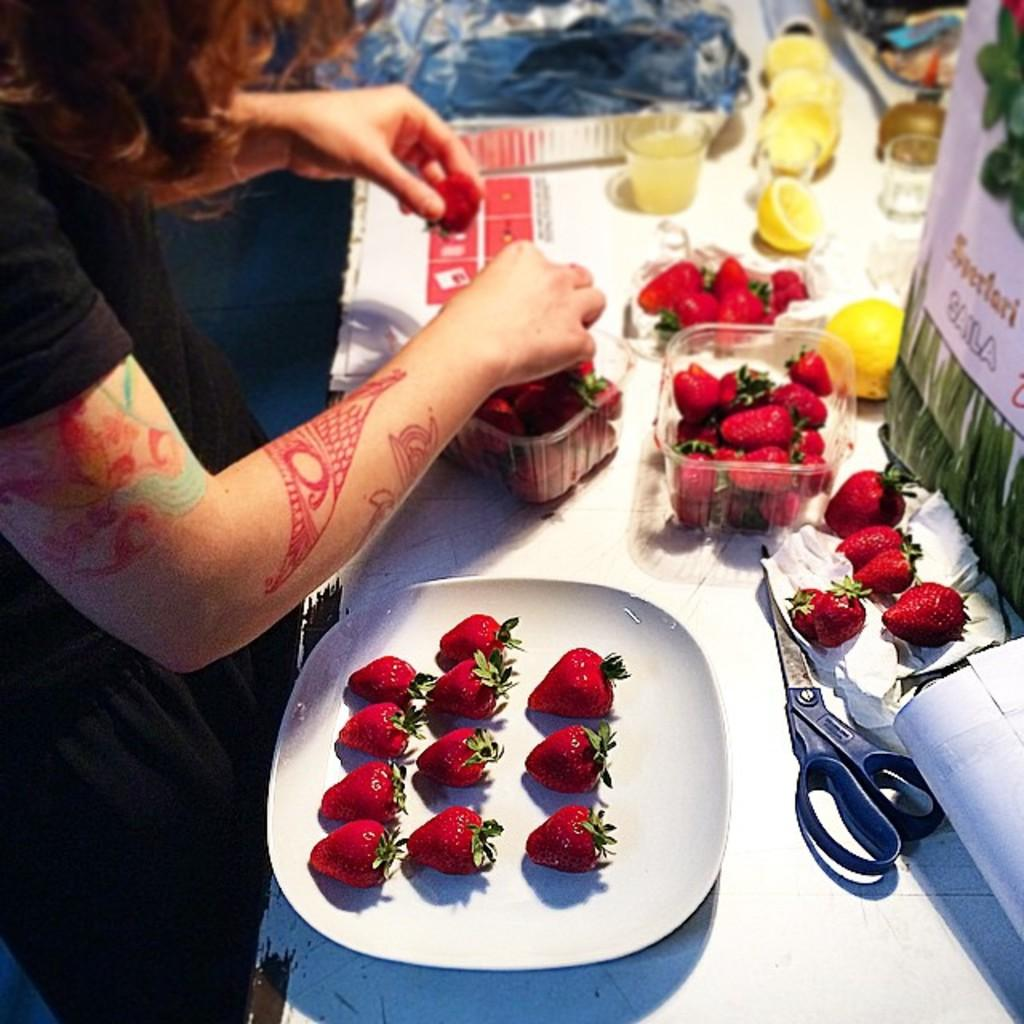Who or what is present in the image? There is a person in the image. What is the person interacting with or near in the image? There is a table in the image. What is on the table that the person might be using or consuming? There is a plate with strawberries on the table. What tools or utensils are on the table that might be used for cutting or preparing the strawberries? There are scissors on the table. What else is on the table that might be related to the strawberries? There are boxes with strawberries on the table. What might the person be drinking from while enjoying the strawberries? There is a glass on the table. What other ingredients or items are on the table that might be used for garnishing or enhancing the strawberries? There are pieces of lemon on the table. Are there any other items on the table that are not mentioned yet? There are some other items on the table. What type of stage is set up for the person in the image? There is no stage present in the image; it is a person at a table with various items related to strawberries. 